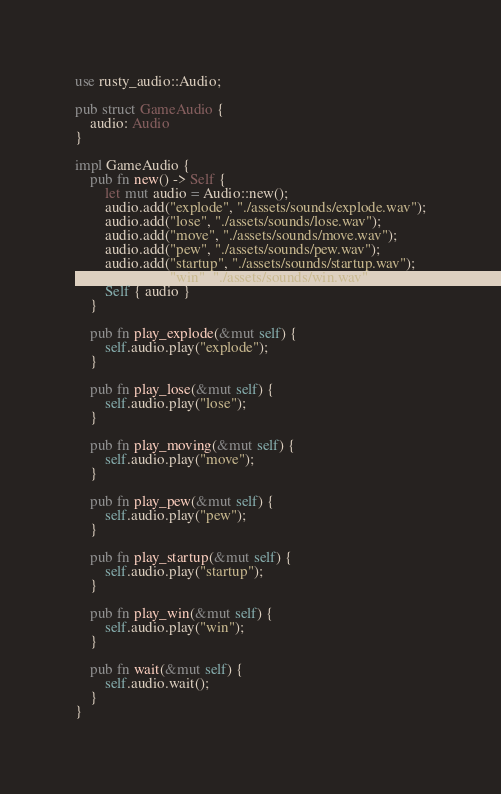<code> <loc_0><loc_0><loc_500><loc_500><_Rust_>use rusty_audio::Audio;

pub struct GameAudio {
    audio: Audio
}

impl GameAudio {
    pub fn new() -> Self {
        let mut audio = Audio::new();
        audio.add("explode", "./assets/sounds/explode.wav");
        audio.add("lose", "./assets/sounds/lose.wav");
        audio.add("move", "./assets/sounds/move.wav");
        audio.add("pew", "./assets/sounds/pew.wav");
        audio.add("startup", "./assets/sounds/startup.wav");
        audio.add("win", "./assets/sounds/win.wav");
        Self { audio }
    }

    pub fn play_explode(&mut self) {
        self.audio.play("explode");
    }

    pub fn play_lose(&mut self) {
        self.audio.play("lose");
    }

    pub fn play_moving(&mut self) {
        self.audio.play("move");
    }

    pub fn play_pew(&mut self) {
        self.audio.play("pew");
    }

    pub fn play_startup(&mut self) {
        self.audio.play("startup");
    }

    pub fn play_win(&mut self) {
        self.audio.play("win");
    }

    pub fn wait(&mut self) {
        self.audio.wait();
    }
}
</code> 